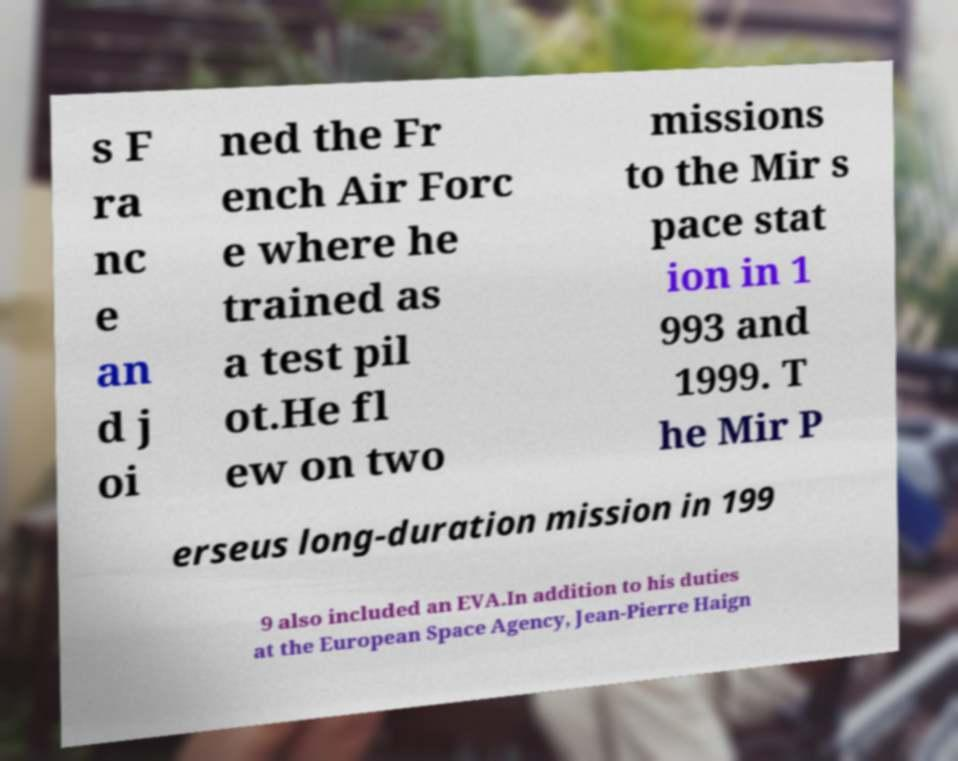I need the written content from this picture converted into text. Can you do that? s F ra nc e an d j oi ned the Fr ench Air Forc e where he trained as a test pil ot.He fl ew on two missions to the Mir s pace stat ion in 1 993 and 1999. T he Mir P erseus long-duration mission in 199 9 also included an EVA.In addition to his duties at the European Space Agency, Jean-Pierre Haign 